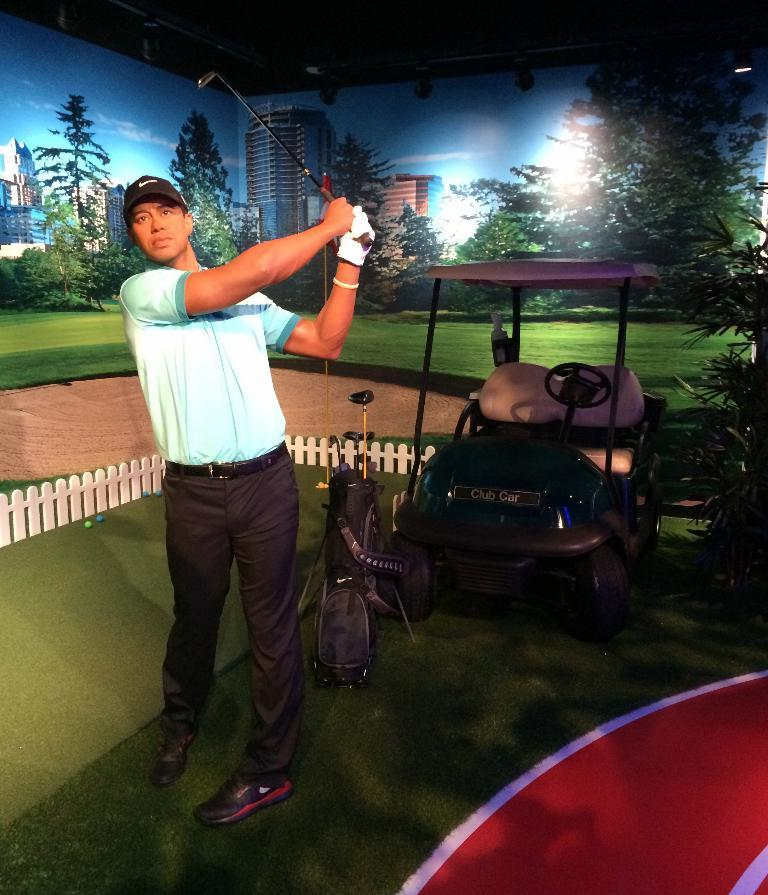Who is present in the image? There is a man in the image. What is the man holding in the image? The man is holding a golf stick. What can be seen in the background of the image? There is a car and banners in the background of the image. What type of terrain is visible at the bottom of the image? There is green grass at the bottom of the image. What type of crown is the man wearing in the image? There is no crown present in the image; the man is holding a golf stick. What flavor of pie can be seen on the table in the image? There is no pie present in the image; the man is holding a golf stick and there is green grass at the bottom of the image. 